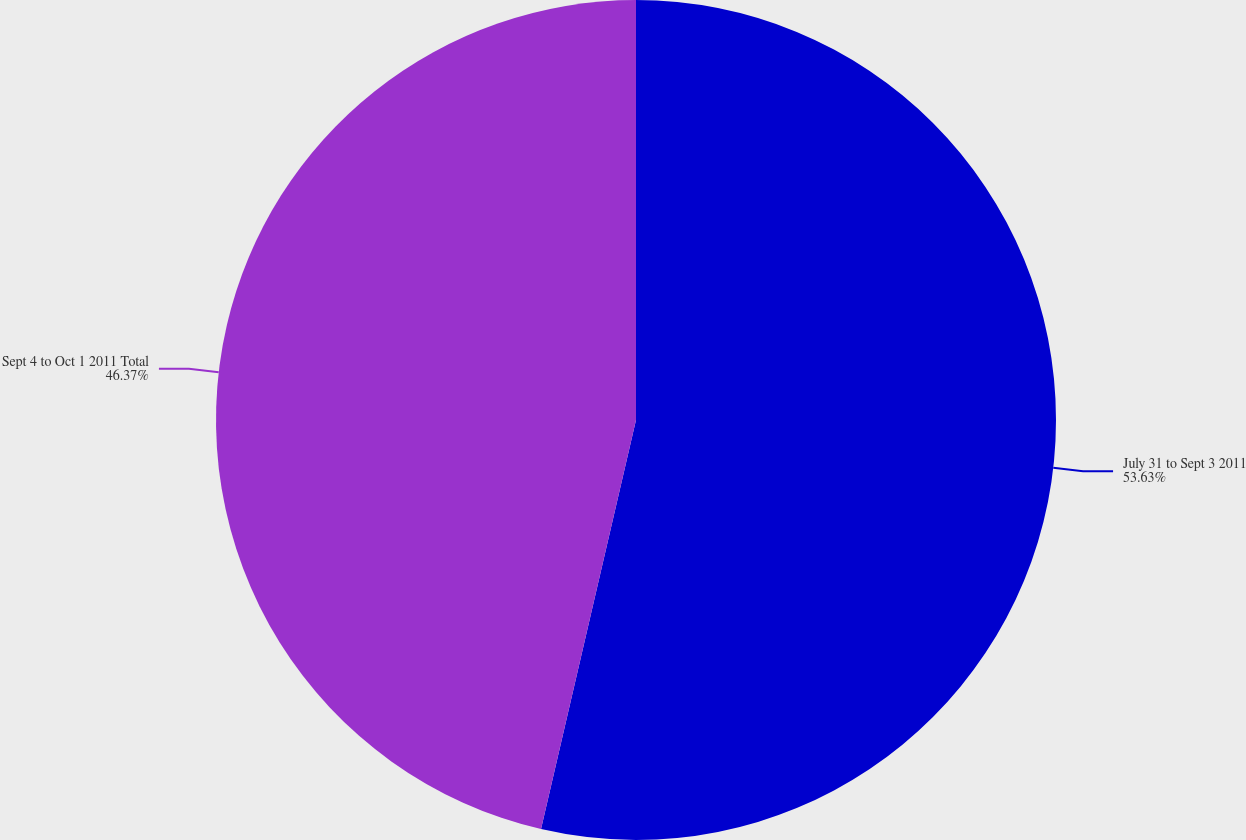<chart> <loc_0><loc_0><loc_500><loc_500><pie_chart><fcel>July 31 to Sept 3 2011<fcel>Sept 4 to Oct 1 2011 Total<nl><fcel>53.63%<fcel>46.37%<nl></chart> 